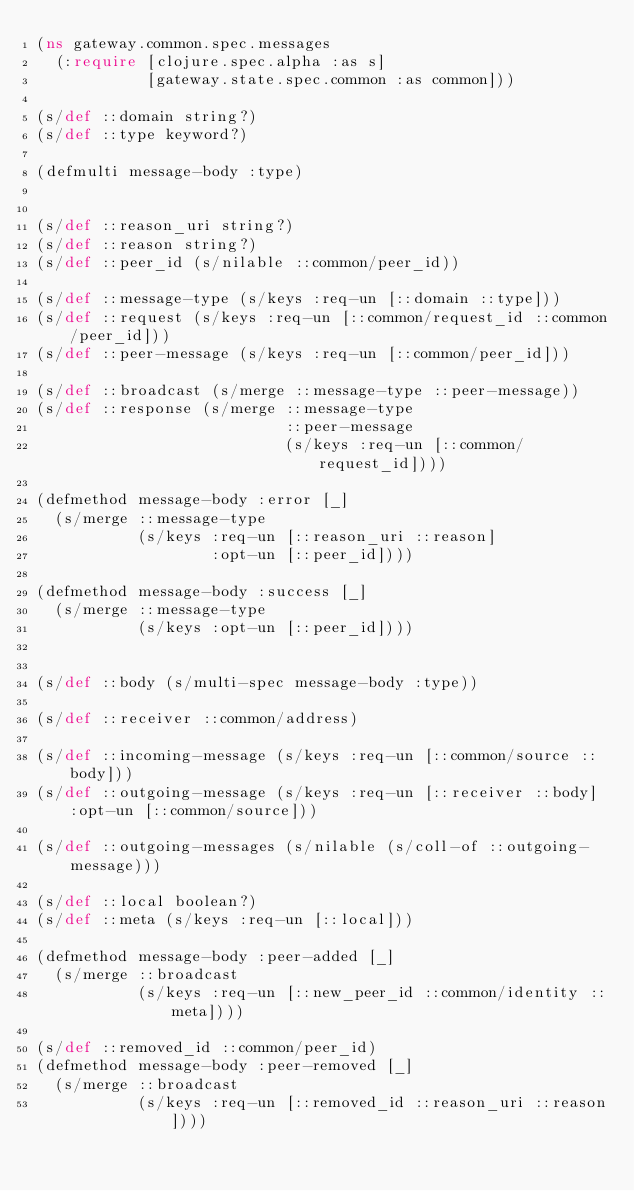Convert code to text. <code><loc_0><loc_0><loc_500><loc_500><_Clojure_>(ns gateway.common.spec.messages
  (:require [clojure.spec.alpha :as s]
            [gateway.state.spec.common :as common]))

(s/def ::domain string?)
(s/def ::type keyword?)

(defmulti message-body :type)


(s/def ::reason_uri string?)
(s/def ::reason string?)
(s/def ::peer_id (s/nilable ::common/peer_id))

(s/def ::message-type (s/keys :req-un [::domain ::type]))
(s/def ::request (s/keys :req-un [::common/request_id ::common/peer_id]))
(s/def ::peer-message (s/keys :req-un [::common/peer_id]))

(s/def ::broadcast (s/merge ::message-type ::peer-message))
(s/def ::response (s/merge ::message-type
                           ::peer-message
                           (s/keys :req-un [::common/request_id])))

(defmethod message-body :error [_]
  (s/merge ::message-type
           (s/keys :req-un [::reason_uri ::reason]
                   :opt-un [::peer_id])))

(defmethod message-body :success [_]
  (s/merge ::message-type
           (s/keys :opt-un [::peer_id])))


(s/def ::body (s/multi-spec message-body :type))

(s/def ::receiver ::common/address)

(s/def ::incoming-message (s/keys :req-un [::common/source ::body]))
(s/def ::outgoing-message (s/keys :req-un [::receiver ::body] :opt-un [::common/source]))

(s/def ::outgoing-messages (s/nilable (s/coll-of ::outgoing-message)))

(s/def ::local boolean?)
(s/def ::meta (s/keys :req-un [::local]))

(defmethod message-body :peer-added [_]
  (s/merge ::broadcast
           (s/keys :req-un [::new_peer_id ::common/identity ::meta])))

(s/def ::removed_id ::common/peer_id)
(defmethod message-body :peer-removed [_]
  (s/merge ::broadcast
           (s/keys :req-un [::removed_id ::reason_uri ::reason])))
</code> 